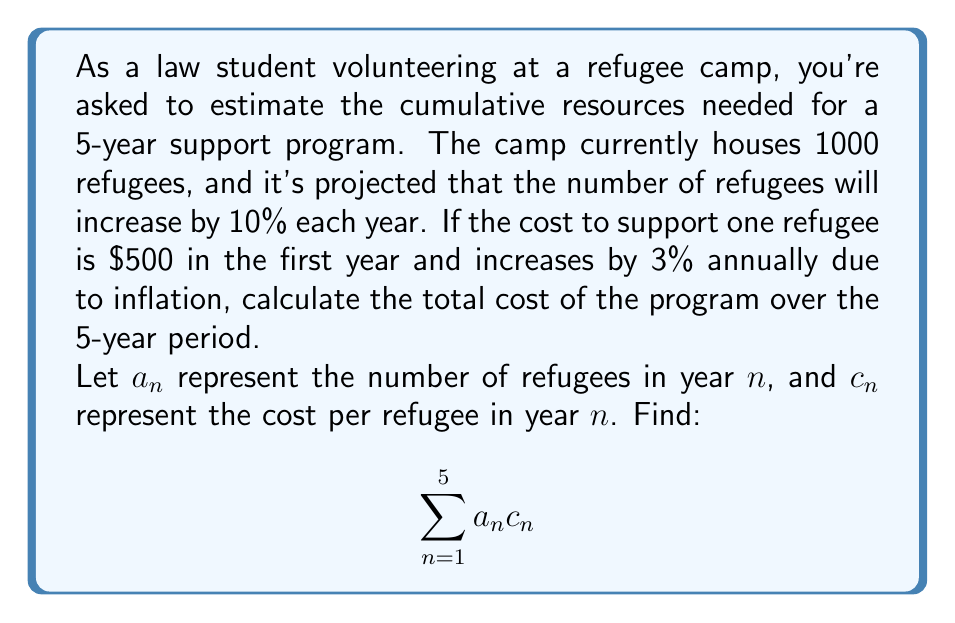What is the answer to this math problem? Let's approach this step-by-step:

1) First, let's define our sequences:

   For the number of refugees: $a_n = 1000 \cdot 1.1^{n-1}$
   For the cost per refugee: $c_n = 500 \cdot 1.03^{n-1}$

2) Now, we need to calculate $a_n c_n$ for each year and sum the results:

   Year 1: $a_1 c_1 = 1000 \cdot 500 = 500,000$

   Year 2: $a_2 c_2 = (1000 \cdot 1.1) \cdot (500 \cdot 1.03) = 566,500$

   Year 3: $a_3 c_3 = (1000 \cdot 1.1^2) \cdot (500 \cdot 1.03^2) = 641,741.25$

   Year 4: $a_4 c_4 = (1000 \cdot 1.1^3) \cdot (500 \cdot 1.03^3) = 726,772.56$

   Year 5: $a_5 c_5 = (1000 \cdot 1.1^4) \cdot (500 \cdot 1.03^4) = 822,752.80$

3) Sum up all these values:

   $\sum_{n=1}^5 a_n c_n = 500,000 + 566,500 + 641,741.25 + 726,772.56 + 822,752.80$

4) Calculate the total:

   $\sum_{n=1}^5 a_n c_n = 3,257,766.61$

Therefore, the total cost of the program over the 5-year period is approximately $3,257,766.61.
Answer: $3,257,766.61 